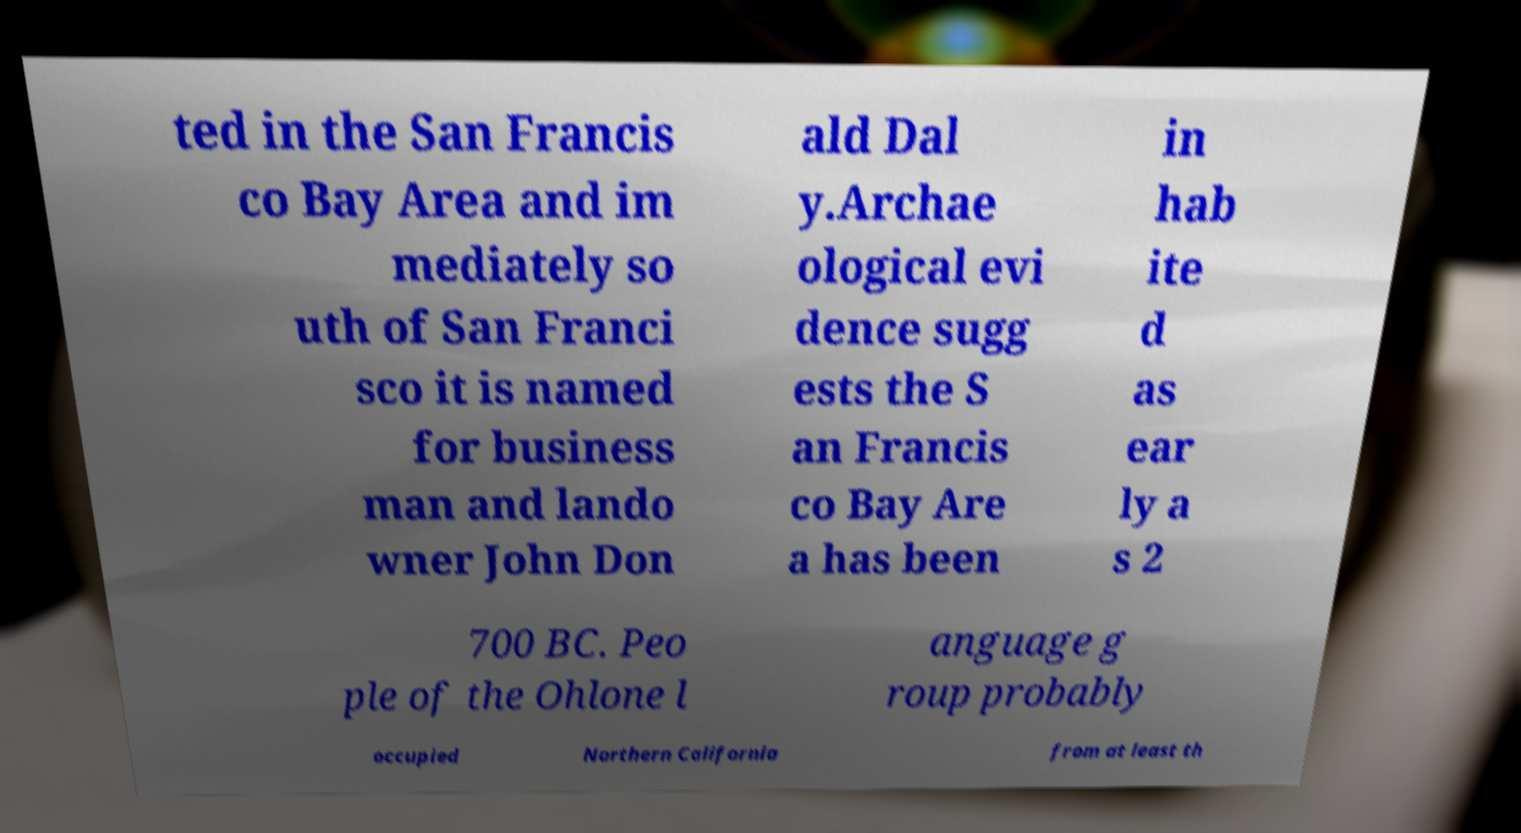Could you extract and type out the text from this image? ted in the San Francis co Bay Area and im mediately so uth of San Franci sco it is named for business man and lando wner John Don ald Dal y.Archae ological evi dence sugg ests the S an Francis co Bay Are a has been in hab ite d as ear ly a s 2 700 BC. Peo ple of the Ohlone l anguage g roup probably occupied Northern California from at least th 